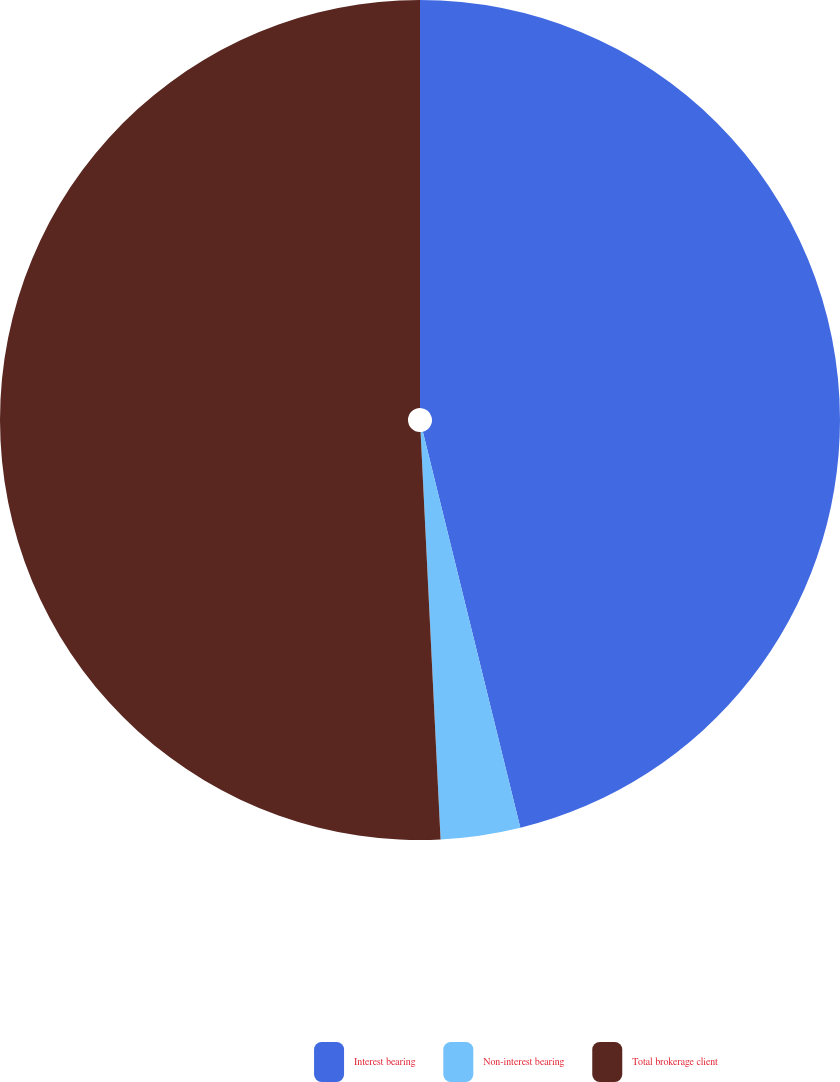Convert chart to OTSL. <chart><loc_0><loc_0><loc_500><loc_500><pie_chart><fcel>Interest bearing<fcel>Non-interest bearing<fcel>Total brokerage client<nl><fcel>46.16%<fcel>3.06%<fcel>50.78%<nl></chart> 